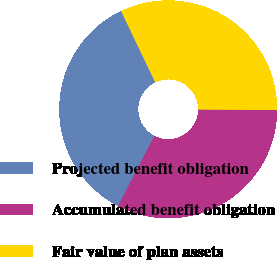Convert chart. <chart><loc_0><loc_0><loc_500><loc_500><pie_chart><fcel>Projected benefit obligation<fcel>Accumulated benefit obligation<fcel>Fair value of plan assets<nl><fcel>35.29%<fcel>32.51%<fcel>32.2%<nl></chart> 